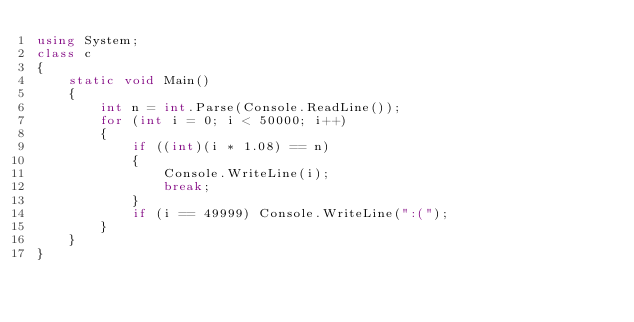<code> <loc_0><loc_0><loc_500><loc_500><_C#_>using System;
class c
{
    static void Main()
    {
        int n = int.Parse(Console.ReadLine());
        for (int i = 0; i < 50000; i++)
        {
            if ((int)(i * 1.08) == n)
            {
                Console.WriteLine(i);
                break;
            }
            if (i == 49999) Console.WriteLine(":(");
        }
    }
}
</code> 